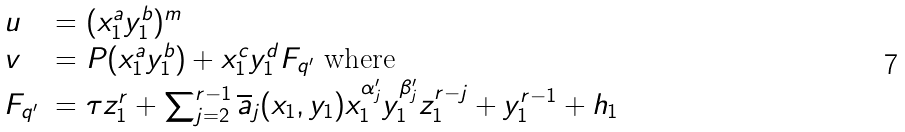<formula> <loc_0><loc_0><loc_500><loc_500>\begin{array} { l l } u & = ( x _ { 1 } ^ { a } y _ { 1 } ^ { b } ) ^ { m } \\ v & = P ( x _ { 1 } ^ { a } y _ { 1 } ^ { b } ) + x _ { 1 } ^ { c } y _ { 1 } ^ { d } F _ { q ^ { \prime } } \text { where} \\ F _ { q ^ { \prime } } & = \tau z _ { 1 } ^ { r } + \sum _ { j = 2 } ^ { r - 1 } \overline { a } _ { j } ( x _ { 1 } , y _ { 1 } ) x _ { 1 } ^ { \alpha _ { j } ^ { \prime } } y _ { 1 } ^ { \beta _ { j } ^ { \prime } } z _ { 1 } ^ { r - j } + y _ { 1 } ^ { r - 1 } + h _ { 1 } \end{array}</formula> 